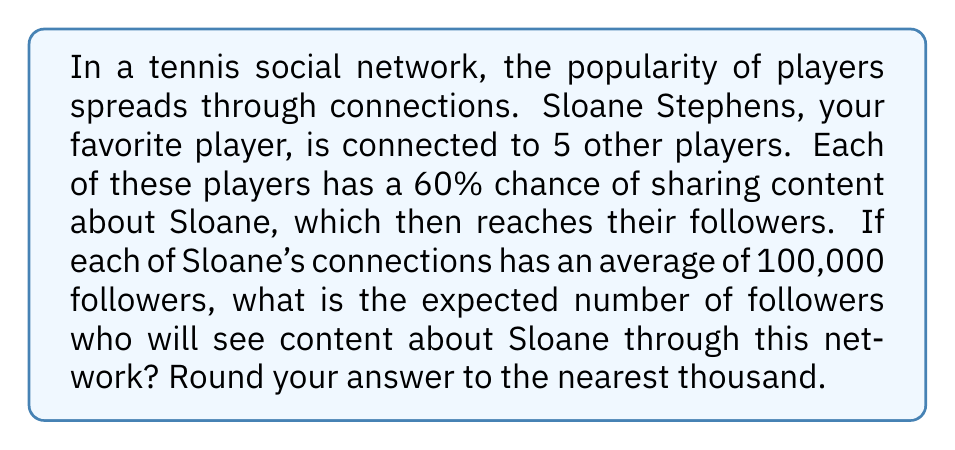Give your solution to this math problem. To solve this problem, we need to follow these steps:

1. Understand the given information:
   - Sloane Stephens is connected to 5 other players
   - Each player has a 60% chance of sharing content about Sloane
   - Each of Sloane's connections has an average of 100,000 followers

2. Calculate the expected number of players who will share content:
   $$\text{Expected sharing players} = 5 \times 0.60 = 3$$

3. Calculate the total number of followers reached:
   $$\text{Total followers} = 3 \times 100,000 = 300,000$$

4. Round the result to the nearest thousand:
   300,000 rounds to 300,000

This problem models the spread of popularity in a simple two-level network, where Sloane's popularity spreads through her immediate connections to their followers. The use of probability (60% chance of sharing) introduces the concept of expected value in network propagation.
Answer: 300,000 followers 